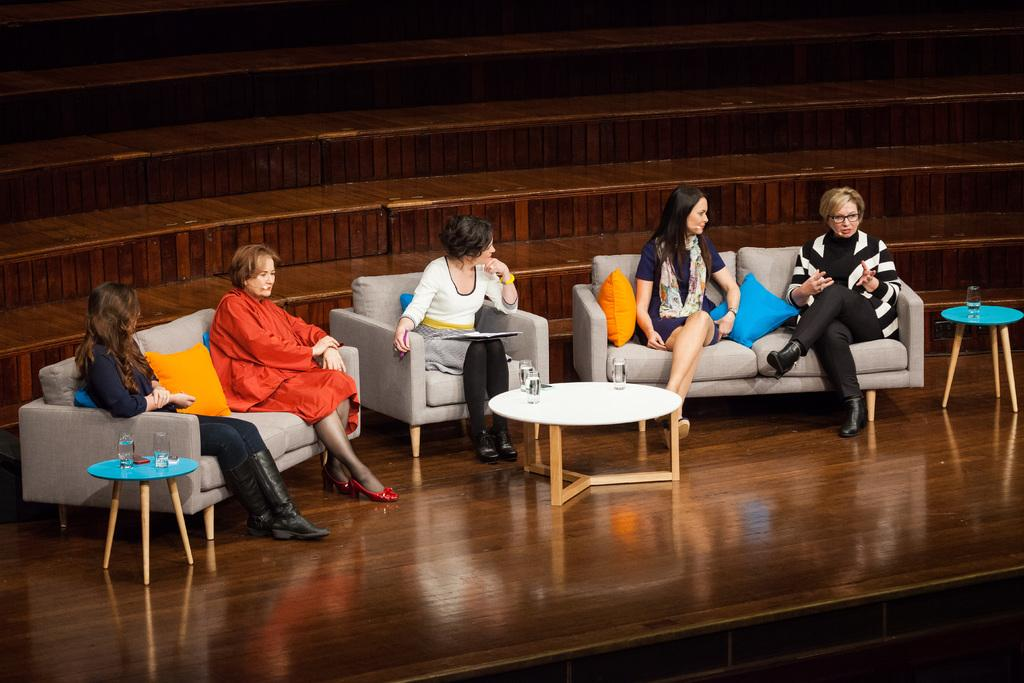What are the women in the image doing? The women are sitting on chairs in the image. Where are the women located in relation to the table? The women are in front of a table in the image. What can be seen on the table? There are water glasses on the table in the image. What type of sticks are the women using to play a song in the image? There are no sticks or any indication of playing a song in the image. 